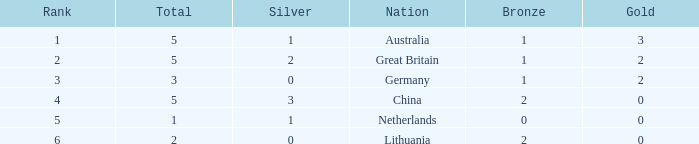What is the ranking number when gold is below 0? None. 